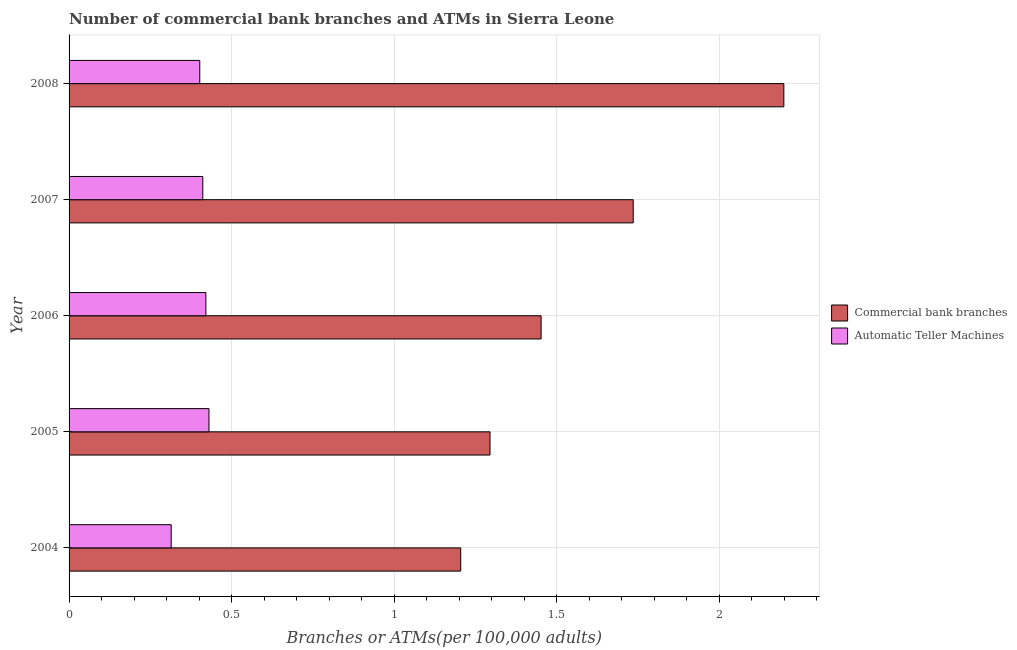How many groups of bars are there?
Make the answer very short. 5. Are the number of bars per tick equal to the number of legend labels?
Provide a succinct answer. Yes. How many bars are there on the 5th tick from the top?
Provide a succinct answer. 2. How many bars are there on the 4th tick from the bottom?
Offer a very short reply. 2. What is the number of commercal bank branches in 2006?
Offer a very short reply. 1.45. Across all years, what is the maximum number of commercal bank branches?
Offer a terse response. 2.2. Across all years, what is the minimum number of commercal bank branches?
Offer a terse response. 1.2. What is the total number of commercal bank branches in the graph?
Your response must be concise. 7.88. What is the difference between the number of commercal bank branches in 2004 and that in 2007?
Offer a very short reply. -0.53. What is the difference between the number of commercal bank branches in 2006 and the number of atms in 2004?
Provide a short and direct response. 1.14. What is the average number of commercal bank branches per year?
Provide a short and direct response. 1.58. In the year 2004, what is the difference between the number of atms and number of commercal bank branches?
Offer a terse response. -0.89. In how many years, is the number of atms greater than 0.7 ?
Keep it short and to the point. 0. What is the ratio of the number of commercal bank branches in 2005 to that in 2007?
Your response must be concise. 0.75. Is the number of commercal bank branches in 2004 less than that in 2006?
Your answer should be very brief. Yes. Is the difference between the number of atms in 2006 and 2008 greater than the difference between the number of commercal bank branches in 2006 and 2008?
Provide a short and direct response. Yes. What is the difference between the highest and the second highest number of commercal bank branches?
Your answer should be compact. 0.46. What is the difference between the highest and the lowest number of atms?
Offer a very short reply. 0.12. Is the sum of the number of commercal bank branches in 2004 and 2005 greater than the maximum number of atms across all years?
Keep it short and to the point. Yes. What does the 2nd bar from the top in 2008 represents?
Make the answer very short. Commercial bank branches. What does the 2nd bar from the bottom in 2007 represents?
Ensure brevity in your answer.  Automatic Teller Machines. How many bars are there?
Offer a very short reply. 10. Are all the bars in the graph horizontal?
Provide a succinct answer. Yes. What is the difference between two consecutive major ticks on the X-axis?
Your answer should be very brief. 0.5. Are the values on the major ticks of X-axis written in scientific E-notation?
Offer a very short reply. No. Where does the legend appear in the graph?
Provide a succinct answer. Center right. What is the title of the graph?
Keep it short and to the point. Number of commercial bank branches and ATMs in Sierra Leone. What is the label or title of the X-axis?
Give a very brief answer. Branches or ATMs(per 100,0 adults). What is the Branches or ATMs(per 100,000 adults) in Commercial bank branches in 2004?
Give a very brief answer. 1.2. What is the Branches or ATMs(per 100,000 adults) of Automatic Teller Machines in 2004?
Your response must be concise. 0.31. What is the Branches or ATMs(per 100,000 adults) of Commercial bank branches in 2005?
Make the answer very short. 1.29. What is the Branches or ATMs(per 100,000 adults) of Automatic Teller Machines in 2005?
Ensure brevity in your answer.  0.43. What is the Branches or ATMs(per 100,000 adults) in Commercial bank branches in 2006?
Ensure brevity in your answer.  1.45. What is the Branches or ATMs(per 100,000 adults) in Automatic Teller Machines in 2006?
Provide a short and direct response. 0.42. What is the Branches or ATMs(per 100,000 adults) in Commercial bank branches in 2007?
Offer a very short reply. 1.73. What is the Branches or ATMs(per 100,000 adults) in Automatic Teller Machines in 2007?
Provide a short and direct response. 0.41. What is the Branches or ATMs(per 100,000 adults) in Commercial bank branches in 2008?
Ensure brevity in your answer.  2.2. What is the Branches or ATMs(per 100,000 adults) of Automatic Teller Machines in 2008?
Give a very brief answer. 0.4. Across all years, what is the maximum Branches or ATMs(per 100,000 adults) of Commercial bank branches?
Your response must be concise. 2.2. Across all years, what is the maximum Branches or ATMs(per 100,000 adults) in Automatic Teller Machines?
Your response must be concise. 0.43. Across all years, what is the minimum Branches or ATMs(per 100,000 adults) in Commercial bank branches?
Make the answer very short. 1.2. Across all years, what is the minimum Branches or ATMs(per 100,000 adults) of Automatic Teller Machines?
Provide a succinct answer. 0.31. What is the total Branches or ATMs(per 100,000 adults) of Commercial bank branches in the graph?
Offer a very short reply. 7.88. What is the total Branches or ATMs(per 100,000 adults) in Automatic Teller Machines in the graph?
Offer a very short reply. 1.98. What is the difference between the Branches or ATMs(per 100,000 adults) of Commercial bank branches in 2004 and that in 2005?
Offer a terse response. -0.09. What is the difference between the Branches or ATMs(per 100,000 adults) of Automatic Teller Machines in 2004 and that in 2005?
Give a very brief answer. -0.12. What is the difference between the Branches or ATMs(per 100,000 adults) of Commercial bank branches in 2004 and that in 2006?
Keep it short and to the point. -0.25. What is the difference between the Branches or ATMs(per 100,000 adults) of Automatic Teller Machines in 2004 and that in 2006?
Offer a very short reply. -0.11. What is the difference between the Branches or ATMs(per 100,000 adults) of Commercial bank branches in 2004 and that in 2007?
Make the answer very short. -0.53. What is the difference between the Branches or ATMs(per 100,000 adults) in Automatic Teller Machines in 2004 and that in 2007?
Your answer should be very brief. -0.1. What is the difference between the Branches or ATMs(per 100,000 adults) in Commercial bank branches in 2004 and that in 2008?
Make the answer very short. -0.99. What is the difference between the Branches or ATMs(per 100,000 adults) of Automatic Teller Machines in 2004 and that in 2008?
Give a very brief answer. -0.09. What is the difference between the Branches or ATMs(per 100,000 adults) in Commercial bank branches in 2005 and that in 2006?
Make the answer very short. -0.16. What is the difference between the Branches or ATMs(per 100,000 adults) in Automatic Teller Machines in 2005 and that in 2006?
Give a very brief answer. 0.01. What is the difference between the Branches or ATMs(per 100,000 adults) of Commercial bank branches in 2005 and that in 2007?
Keep it short and to the point. -0.44. What is the difference between the Branches or ATMs(per 100,000 adults) of Automatic Teller Machines in 2005 and that in 2007?
Ensure brevity in your answer.  0.02. What is the difference between the Branches or ATMs(per 100,000 adults) of Commercial bank branches in 2005 and that in 2008?
Provide a succinct answer. -0.9. What is the difference between the Branches or ATMs(per 100,000 adults) in Automatic Teller Machines in 2005 and that in 2008?
Give a very brief answer. 0.03. What is the difference between the Branches or ATMs(per 100,000 adults) of Commercial bank branches in 2006 and that in 2007?
Make the answer very short. -0.28. What is the difference between the Branches or ATMs(per 100,000 adults) in Automatic Teller Machines in 2006 and that in 2007?
Give a very brief answer. 0.01. What is the difference between the Branches or ATMs(per 100,000 adults) in Commercial bank branches in 2006 and that in 2008?
Make the answer very short. -0.75. What is the difference between the Branches or ATMs(per 100,000 adults) of Automatic Teller Machines in 2006 and that in 2008?
Provide a succinct answer. 0.02. What is the difference between the Branches or ATMs(per 100,000 adults) in Commercial bank branches in 2007 and that in 2008?
Ensure brevity in your answer.  -0.46. What is the difference between the Branches or ATMs(per 100,000 adults) in Automatic Teller Machines in 2007 and that in 2008?
Your answer should be very brief. 0.01. What is the difference between the Branches or ATMs(per 100,000 adults) of Commercial bank branches in 2004 and the Branches or ATMs(per 100,000 adults) of Automatic Teller Machines in 2005?
Ensure brevity in your answer.  0.77. What is the difference between the Branches or ATMs(per 100,000 adults) in Commercial bank branches in 2004 and the Branches or ATMs(per 100,000 adults) in Automatic Teller Machines in 2006?
Provide a succinct answer. 0.78. What is the difference between the Branches or ATMs(per 100,000 adults) in Commercial bank branches in 2004 and the Branches or ATMs(per 100,000 adults) in Automatic Teller Machines in 2007?
Offer a terse response. 0.79. What is the difference between the Branches or ATMs(per 100,000 adults) in Commercial bank branches in 2004 and the Branches or ATMs(per 100,000 adults) in Automatic Teller Machines in 2008?
Ensure brevity in your answer.  0.8. What is the difference between the Branches or ATMs(per 100,000 adults) of Commercial bank branches in 2005 and the Branches or ATMs(per 100,000 adults) of Automatic Teller Machines in 2006?
Give a very brief answer. 0.87. What is the difference between the Branches or ATMs(per 100,000 adults) in Commercial bank branches in 2005 and the Branches or ATMs(per 100,000 adults) in Automatic Teller Machines in 2007?
Your answer should be very brief. 0.88. What is the difference between the Branches or ATMs(per 100,000 adults) of Commercial bank branches in 2005 and the Branches or ATMs(per 100,000 adults) of Automatic Teller Machines in 2008?
Your response must be concise. 0.89. What is the difference between the Branches or ATMs(per 100,000 adults) of Commercial bank branches in 2006 and the Branches or ATMs(per 100,000 adults) of Automatic Teller Machines in 2007?
Provide a short and direct response. 1.04. What is the difference between the Branches or ATMs(per 100,000 adults) of Commercial bank branches in 2006 and the Branches or ATMs(per 100,000 adults) of Automatic Teller Machines in 2008?
Give a very brief answer. 1.05. What is the difference between the Branches or ATMs(per 100,000 adults) of Commercial bank branches in 2007 and the Branches or ATMs(per 100,000 adults) of Automatic Teller Machines in 2008?
Offer a very short reply. 1.33. What is the average Branches or ATMs(per 100,000 adults) in Commercial bank branches per year?
Ensure brevity in your answer.  1.58. What is the average Branches or ATMs(per 100,000 adults) of Automatic Teller Machines per year?
Keep it short and to the point. 0.4. In the year 2004, what is the difference between the Branches or ATMs(per 100,000 adults) in Commercial bank branches and Branches or ATMs(per 100,000 adults) in Automatic Teller Machines?
Your response must be concise. 0.89. In the year 2005, what is the difference between the Branches or ATMs(per 100,000 adults) of Commercial bank branches and Branches or ATMs(per 100,000 adults) of Automatic Teller Machines?
Provide a succinct answer. 0.86. In the year 2006, what is the difference between the Branches or ATMs(per 100,000 adults) of Commercial bank branches and Branches or ATMs(per 100,000 adults) of Automatic Teller Machines?
Offer a very short reply. 1.03. In the year 2007, what is the difference between the Branches or ATMs(per 100,000 adults) in Commercial bank branches and Branches or ATMs(per 100,000 adults) in Automatic Teller Machines?
Your response must be concise. 1.32. In the year 2008, what is the difference between the Branches or ATMs(per 100,000 adults) in Commercial bank branches and Branches or ATMs(per 100,000 adults) in Automatic Teller Machines?
Ensure brevity in your answer.  1.8. What is the ratio of the Branches or ATMs(per 100,000 adults) in Commercial bank branches in 2004 to that in 2005?
Offer a terse response. 0.93. What is the ratio of the Branches or ATMs(per 100,000 adults) of Automatic Teller Machines in 2004 to that in 2005?
Offer a very short reply. 0.73. What is the ratio of the Branches or ATMs(per 100,000 adults) of Commercial bank branches in 2004 to that in 2006?
Offer a terse response. 0.83. What is the ratio of the Branches or ATMs(per 100,000 adults) of Automatic Teller Machines in 2004 to that in 2006?
Make the answer very short. 0.75. What is the ratio of the Branches or ATMs(per 100,000 adults) in Commercial bank branches in 2004 to that in 2007?
Your answer should be very brief. 0.69. What is the ratio of the Branches or ATMs(per 100,000 adults) of Automatic Teller Machines in 2004 to that in 2007?
Your answer should be compact. 0.76. What is the ratio of the Branches or ATMs(per 100,000 adults) in Commercial bank branches in 2004 to that in 2008?
Your answer should be compact. 0.55. What is the ratio of the Branches or ATMs(per 100,000 adults) of Automatic Teller Machines in 2004 to that in 2008?
Keep it short and to the point. 0.78. What is the ratio of the Branches or ATMs(per 100,000 adults) of Commercial bank branches in 2005 to that in 2006?
Keep it short and to the point. 0.89. What is the ratio of the Branches or ATMs(per 100,000 adults) of Automatic Teller Machines in 2005 to that in 2006?
Your response must be concise. 1.02. What is the ratio of the Branches or ATMs(per 100,000 adults) in Commercial bank branches in 2005 to that in 2007?
Your answer should be very brief. 0.75. What is the ratio of the Branches or ATMs(per 100,000 adults) in Automatic Teller Machines in 2005 to that in 2007?
Your response must be concise. 1.05. What is the ratio of the Branches or ATMs(per 100,000 adults) of Commercial bank branches in 2005 to that in 2008?
Give a very brief answer. 0.59. What is the ratio of the Branches or ATMs(per 100,000 adults) in Automatic Teller Machines in 2005 to that in 2008?
Ensure brevity in your answer.  1.07. What is the ratio of the Branches or ATMs(per 100,000 adults) of Commercial bank branches in 2006 to that in 2007?
Make the answer very short. 0.84. What is the ratio of the Branches or ATMs(per 100,000 adults) in Automatic Teller Machines in 2006 to that in 2007?
Keep it short and to the point. 1.02. What is the ratio of the Branches or ATMs(per 100,000 adults) in Commercial bank branches in 2006 to that in 2008?
Make the answer very short. 0.66. What is the ratio of the Branches or ATMs(per 100,000 adults) of Automatic Teller Machines in 2006 to that in 2008?
Provide a succinct answer. 1.05. What is the ratio of the Branches or ATMs(per 100,000 adults) in Commercial bank branches in 2007 to that in 2008?
Keep it short and to the point. 0.79. What is the ratio of the Branches or ATMs(per 100,000 adults) in Automatic Teller Machines in 2007 to that in 2008?
Provide a short and direct response. 1.02. What is the difference between the highest and the second highest Branches or ATMs(per 100,000 adults) of Commercial bank branches?
Your answer should be very brief. 0.46. What is the difference between the highest and the second highest Branches or ATMs(per 100,000 adults) of Automatic Teller Machines?
Ensure brevity in your answer.  0.01. What is the difference between the highest and the lowest Branches or ATMs(per 100,000 adults) in Automatic Teller Machines?
Your answer should be compact. 0.12. 